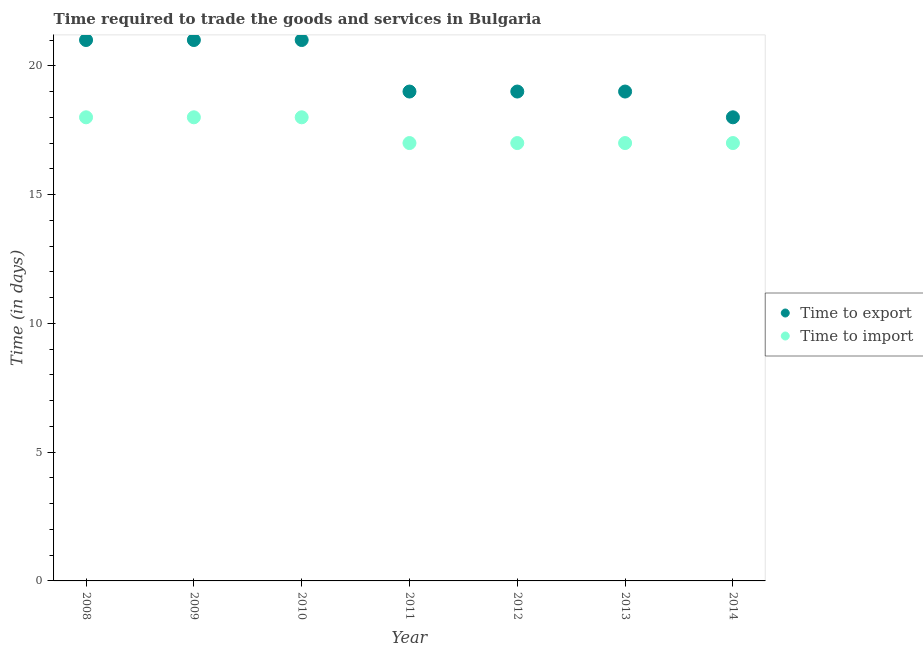How many different coloured dotlines are there?
Offer a very short reply. 2. What is the time to import in 2010?
Offer a very short reply. 18. Across all years, what is the maximum time to export?
Give a very brief answer. 21. Across all years, what is the minimum time to export?
Keep it short and to the point. 18. In which year was the time to import minimum?
Offer a terse response. 2011. What is the total time to import in the graph?
Give a very brief answer. 122. What is the difference between the time to export in 2013 and that in 2014?
Provide a succinct answer. 1. What is the difference between the time to export in 2014 and the time to import in 2012?
Your answer should be very brief. 1. What is the average time to import per year?
Provide a short and direct response. 17.43. In the year 2008, what is the difference between the time to export and time to import?
Provide a short and direct response. 3. What is the ratio of the time to export in 2008 to that in 2014?
Offer a terse response. 1.17. What is the difference between the highest and the lowest time to import?
Your answer should be compact. 1. In how many years, is the time to import greater than the average time to import taken over all years?
Your response must be concise. 3. Is the sum of the time to import in 2010 and 2012 greater than the maximum time to export across all years?
Offer a terse response. Yes. How many years are there in the graph?
Provide a succinct answer. 7. What is the difference between two consecutive major ticks on the Y-axis?
Your answer should be very brief. 5. Does the graph contain any zero values?
Provide a succinct answer. No. What is the title of the graph?
Keep it short and to the point. Time required to trade the goods and services in Bulgaria. Does "Private credit bureau" appear as one of the legend labels in the graph?
Offer a terse response. No. What is the label or title of the X-axis?
Offer a very short reply. Year. What is the label or title of the Y-axis?
Give a very brief answer. Time (in days). What is the Time (in days) in Time to export in 2008?
Make the answer very short. 21. What is the Time (in days) in Time to import in 2009?
Ensure brevity in your answer.  18. What is the Time (in days) in Time to export in 2011?
Ensure brevity in your answer.  19. What is the Time (in days) of Time to export in 2012?
Your answer should be compact. 19. What is the Time (in days) in Time to export in 2013?
Offer a terse response. 19. What is the Time (in days) of Time to import in 2013?
Make the answer very short. 17. What is the Time (in days) in Time to export in 2014?
Give a very brief answer. 18. Across all years, what is the maximum Time (in days) of Time to export?
Your answer should be compact. 21. Across all years, what is the maximum Time (in days) in Time to import?
Make the answer very short. 18. Across all years, what is the minimum Time (in days) in Time to import?
Ensure brevity in your answer.  17. What is the total Time (in days) of Time to export in the graph?
Provide a succinct answer. 138. What is the total Time (in days) of Time to import in the graph?
Your response must be concise. 122. What is the difference between the Time (in days) of Time to import in 2008 and that in 2009?
Your response must be concise. 0. What is the difference between the Time (in days) of Time to export in 2008 and that in 2010?
Provide a short and direct response. 0. What is the difference between the Time (in days) of Time to export in 2008 and that in 2012?
Give a very brief answer. 2. What is the difference between the Time (in days) of Time to export in 2008 and that in 2014?
Offer a terse response. 3. What is the difference between the Time (in days) of Time to export in 2009 and that in 2011?
Provide a short and direct response. 2. What is the difference between the Time (in days) of Time to import in 2009 and that in 2011?
Give a very brief answer. 1. What is the difference between the Time (in days) of Time to export in 2009 and that in 2013?
Give a very brief answer. 2. What is the difference between the Time (in days) of Time to import in 2009 and that in 2014?
Make the answer very short. 1. What is the difference between the Time (in days) in Time to export in 2010 and that in 2011?
Offer a terse response. 2. What is the difference between the Time (in days) in Time to export in 2010 and that in 2012?
Your response must be concise. 2. What is the difference between the Time (in days) in Time to import in 2010 and that in 2012?
Keep it short and to the point. 1. What is the difference between the Time (in days) in Time to export in 2010 and that in 2013?
Your answer should be very brief. 2. What is the difference between the Time (in days) of Time to import in 2010 and that in 2013?
Your answer should be very brief. 1. What is the difference between the Time (in days) of Time to export in 2010 and that in 2014?
Offer a terse response. 3. What is the difference between the Time (in days) of Time to import in 2011 and that in 2012?
Your answer should be compact. 0. What is the difference between the Time (in days) in Time to export in 2011 and that in 2013?
Make the answer very short. 0. What is the difference between the Time (in days) of Time to export in 2011 and that in 2014?
Offer a very short reply. 1. What is the difference between the Time (in days) of Time to import in 2011 and that in 2014?
Make the answer very short. 0. What is the difference between the Time (in days) in Time to export in 2012 and that in 2014?
Keep it short and to the point. 1. What is the difference between the Time (in days) of Time to import in 2013 and that in 2014?
Your answer should be very brief. 0. What is the difference between the Time (in days) of Time to export in 2008 and the Time (in days) of Time to import in 2010?
Ensure brevity in your answer.  3. What is the difference between the Time (in days) of Time to export in 2008 and the Time (in days) of Time to import in 2012?
Ensure brevity in your answer.  4. What is the difference between the Time (in days) of Time to export in 2009 and the Time (in days) of Time to import in 2012?
Your answer should be compact. 4. What is the difference between the Time (in days) of Time to export in 2009 and the Time (in days) of Time to import in 2013?
Keep it short and to the point. 4. What is the difference between the Time (in days) in Time to export in 2009 and the Time (in days) in Time to import in 2014?
Offer a terse response. 4. What is the difference between the Time (in days) in Time to export in 2010 and the Time (in days) in Time to import in 2012?
Your response must be concise. 4. What is the difference between the Time (in days) of Time to export in 2011 and the Time (in days) of Time to import in 2014?
Make the answer very short. 2. What is the difference between the Time (in days) of Time to export in 2012 and the Time (in days) of Time to import in 2014?
Make the answer very short. 2. What is the average Time (in days) in Time to export per year?
Make the answer very short. 19.71. What is the average Time (in days) of Time to import per year?
Offer a very short reply. 17.43. In the year 2009, what is the difference between the Time (in days) of Time to export and Time (in days) of Time to import?
Your response must be concise. 3. In the year 2011, what is the difference between the Time (in days) of Time to export and Time (in days) of Time to import?
Offer a very short reply. 2. In the year 2013, what is the difference between the Time (in days) in Time to export and Time (in days) in Time to import?
Keep it short and to the point. 2. What is the ratio of the Time (in days) in Time to export in 2008 to that in 2009?
Ensure brevity in your answer.  1. What is the ratio of the Time (in days) in Time to import in 2008 to that in 2009?
Keep it short and to the point. 1. What is the ratio of the Time (in days) of Time to export in 2008 to that in 2010?
Provide a short and direct response. 1. What is the ratio of the Time (in days) in Time to export in 2008 to that in 2011?
Offer a terse response. 1.11. What is the ratio of the Time (in days) in Time to import in 2008 to that in 2011?
Offer a terse response. 1.06. What is the ratio of the Time (in days) of Time to export in 2008 to that in 2012?
Your answer should be compact. 1.11. What is the ratio of the Time (in days) in Time to import in 2008 to that in 2012?
Ensure brevity in your answer.  1.06. What is the ratio of the Time (in days) of Time to export in 2008 to that in 2013?
Your answer should be compact. 1.11. What is the ratio of the Time (in days) in Time to import in 2008 to that in 2013?
Provide a succinct answer. 1.06. What is the ratio of the Time (in days) of Time to import in 2008 to that in 2014?
Your answer should be very brief. 1.06. What is the ratio of the Time (in days) in Time to export in 2009 to that in 2010?
Ensure brevity in your answer.  1. What is the ratio of the Time (in days) of Time to export in 2009 to that in 2011?
Your answer should be compact. 1.11. What is the ratio of the Time (in days) in Time to import in 2009 to that in 2011?
Offer a very short reply. 1.06. What is the ratio of the Time (in days) of Time to export in 2009 to that in 2012?
Make the answer very short. 1.11. What is the ratio of the Time (in days) in Time to import in 2009 to that in 2012?
Make the answer very short. 1.06. What is the ratio of the Time (in days) in Time to export in 2009 to that in 2013?
Give a very brief answer. 1.11. What is the ratio of the Time (in days) in Time to import in 2009 to that in 2013?
Give a very brief answer. 1.06. What is the ratio of the Time (in days) in Time to import in 2009 to that in 2014?
Make the answer very short. 1.06. What is the ratio of the Time (in days) of Time to export in 2010 to that in 2011?
Offer a terse response. 1.11. What is the ratio of the Time (in days) in Time to import in 2010 to that in 2011?
Provide a succinct answer. 1.06. What is the ratio of the Time (in days) in Time to export in 2010 to that in 2012?
Provide a succinct answer. 1.11. What is the ratio of the Time (in days) in Time to import in 2010 to that in 2012?
Provide a succinct answer. 1.06. What is the ratio of the Time (in days) of Time to export in 2010 to that in 2013?
Provide a short and direct response. 1.11. What is the ratio of the Time (in days) of Time to import in 2010 to that in 2013?
Your answer should be very brief. 1.06. What is the ratio of the Time (in days) in Time to export in 2010 to that in 2014?
Keep it short and to the point. 1.17. What is the ratio of the Time (in days) of Time to import in 2010 to that in 2014?
Offer a terse response. 1.06. What is the ratio of the Time (in days) in Time to import in 2011 to that in 2012?
Offer a terse response. 1. What is the ratio of the Time (in days) in Time to export in 2011 to that in 2013?
Offer a very short reply. 1. What is the ratio of the Time (in days) of Time to import in 2011 to that in 2013?
Give a very brief answer. 1. What is the ratio of the Time (in days) of Time to export in 2011 to that in 2014?
Provide a succinct answer. 1.06. What is the ratio of the Time (in days) of Time to import in 2011 to that in 2014?
Make the answer very short. 1. What is the ratio of the Time (in days) of Time to import in 2012 to that in 2013?
Give a very brief answer. 1. What is the ratio of the Time (in days) in Time to export in 2012 to that in 2014?
Your answer should be compact. 1.06. What is the ratio of the Time (in days) of Time to export in 2013 to that in 2014?
Provide a succinct answer. 1.06. What is the ratio of the Time (in days) of Time to import in 2013 to that in 2014?
Your answer should be very brief. 1. What is the difference between the highest and the lowest Time (in days) of Time to import?
Your answer should be compact. 1. 